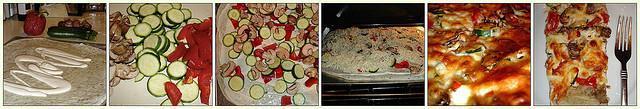How many forks are visible?
Give a very brief answer. 1. How many pizzas are visible?
Give a very brief answer. 2. 